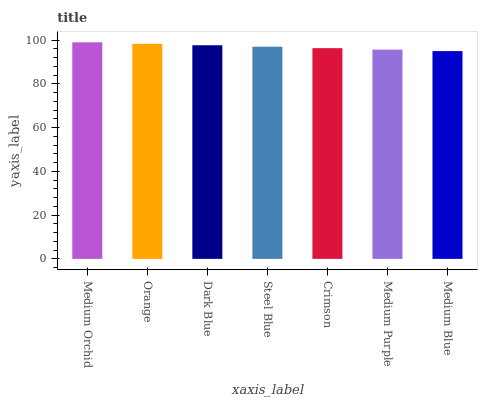Is Medium Blue the minimum?
Answer yes or no. Yes. Is Medium Orchid the maximum?
Answer yes or no. Yes. Is Orange the minimum?
Answer yes or no. No. Is Orange the maximum?
Answer yes or no. No. Is Medium Orchid greater than Orange?
Answer yes or no. Yes. Is Orange less than Medium Orchid?
Answer yes or no. Yes. Is Orange greater than Medium Orchid?
Answer yes or no. No. Is Medium Orchid less than Orange?
Answer yes or no. No. Is Steel Blue the high median?
Answer yes or no. Yes. Is Steel Blue the low median?
Answer yes or no. Yes. Is Medium Purple the high median?
Answer yes or no. No. Is Medium Blue the low median?
Answer yes or no. No. 